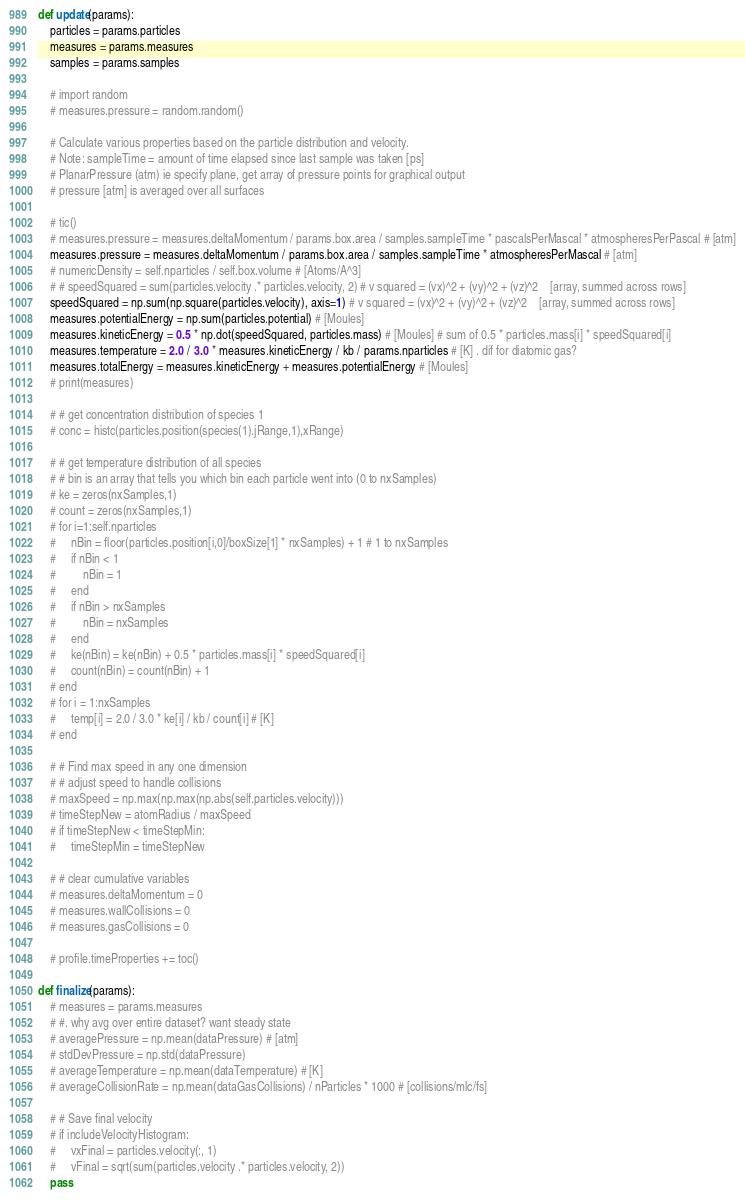<code> <loc_0><loc_0><loc_500><loc_500><_Python_>

def update(params):
    particles = params.particles
    measures = params.measures
    samples = params.samples

    # import random
    # measures.pressure = random.random()

    # Calculate various properties based on the particle distribution and velocity. 
    # Note: sampleTime = amount of time elapsed since last sample was taken [ps]
    # PlanarPressure (atm) ie specify plane, get array of pressure points for graphical output
    # pressure [atm] is averaged over all surfaces

    # tic()
    # measures.pressure = measures.deltaMomentum / params.box.area / samples.sampleTime * pascalsPerMascal * atmospheresPerPascal # [atm]
    measures.pressure = measures.deltaMomentum / params.box.area / samples.sampleTime * atmospheresPerMascal # [atm]
    # numericDensity = self.nparticles / self.box.volume # [Atoms/A^3]
    # # speedSquared = sum(particles.velocity .* particles.velocity, 2) # v squared = (vx)^2 + (vy)^2 + (vz)^2    [array, summed across rows]
    speedSquared = np.sum(np.square(particles.velocity), axis=1) # v squared = (vx)^2 + (vy)^2 + (vz)^2    [array, summed across rows]
    measures.potentialEnergy = np.sum(particles.potential) # [Moules]
    measures.kineticEnergy = 0.5 * np.dot(speedSquared, particles.mass) # [Moules] # sum of 0.5 * particles.mass[i] * speedSquared[i]
    measures.temperature = 2.0 / 3.0 * measures.kineticEnergy / kb / params.nparticles # [K] . dif for diatomic gas?
    measures.totalEnergy = measures.kineticEnergy + measures.potentialEnergy # [Moules]
    # print(measures)

    # # get concentration distribution of species 1
    # conc = histc(particles.position(species(1).jRange,1),xRange)

    # # get temperature distribution of all species
    # # bin is an array that tells you which bin each particle went into (0 to nxSamples)
    # ke = zeros(nxSamples,1)
    # count = zeros(nxSamples,1)
    # for i=1:self.nparticles
    #     nBin = floor(particles.position[i,0]/boxSize[1] * nxSamples) + 1 # 1 to nxSamples
    #     if nBin < 1 
    #         nBin = 1
    #     end
    #     if nBin > nxSamples
    #         nBin = nxSamples
    #     end
    #     ke(nBin) = ke(nBin) + 0.5 * particles.mass[i] * speedSquared[i]
    #     count(nBin) = count(nBin) + 1
    # end
    # for i = 1:nxSamples
    #     temp[i] = 2.0 / 3.0 * ke[i] / kb / count[i] # [K]
    # end

    # # Find max speed in any one dimension
    # # adjust speed to handle collisions
    # maxSpeed = np.max(np.max(np.abs(self.particles.velocity)))
    # timeStepNew = atomRadius / maxSpeed
    # if timeStepNew < timeStepMin:
    #     timeStepMin = timeStepNew

    # # clear cumulative variables
    # measures.deltaMomentum = 0
    # measures.wallCollisions = 0
    # measures.gasCollisions = 0

    # profile.timeProperties += toc()

def finalize(params):
    # measures = params.measures
    # #. why avg over entire dataset? want steady state
    # averagePressure = np.mean(dataPressure) # [atm]
    # stdDevPressure = np.std(dataPressure)
    # averageTemperature = np.mean(dataTemperature) # [K]
    # averageCollisionRate = np.mean(dataGasCollisions) / nParticles * 1000 # [collisions/mlc/fs]

    # # Save final velocity
    # if includeVelocityHistogram:
    #     vxFinal = particles.velocity(:, 1)
    #     vFinal = sqrt(sum(particles.velocity .* particles.velocity, 2))
    pass

</code> 